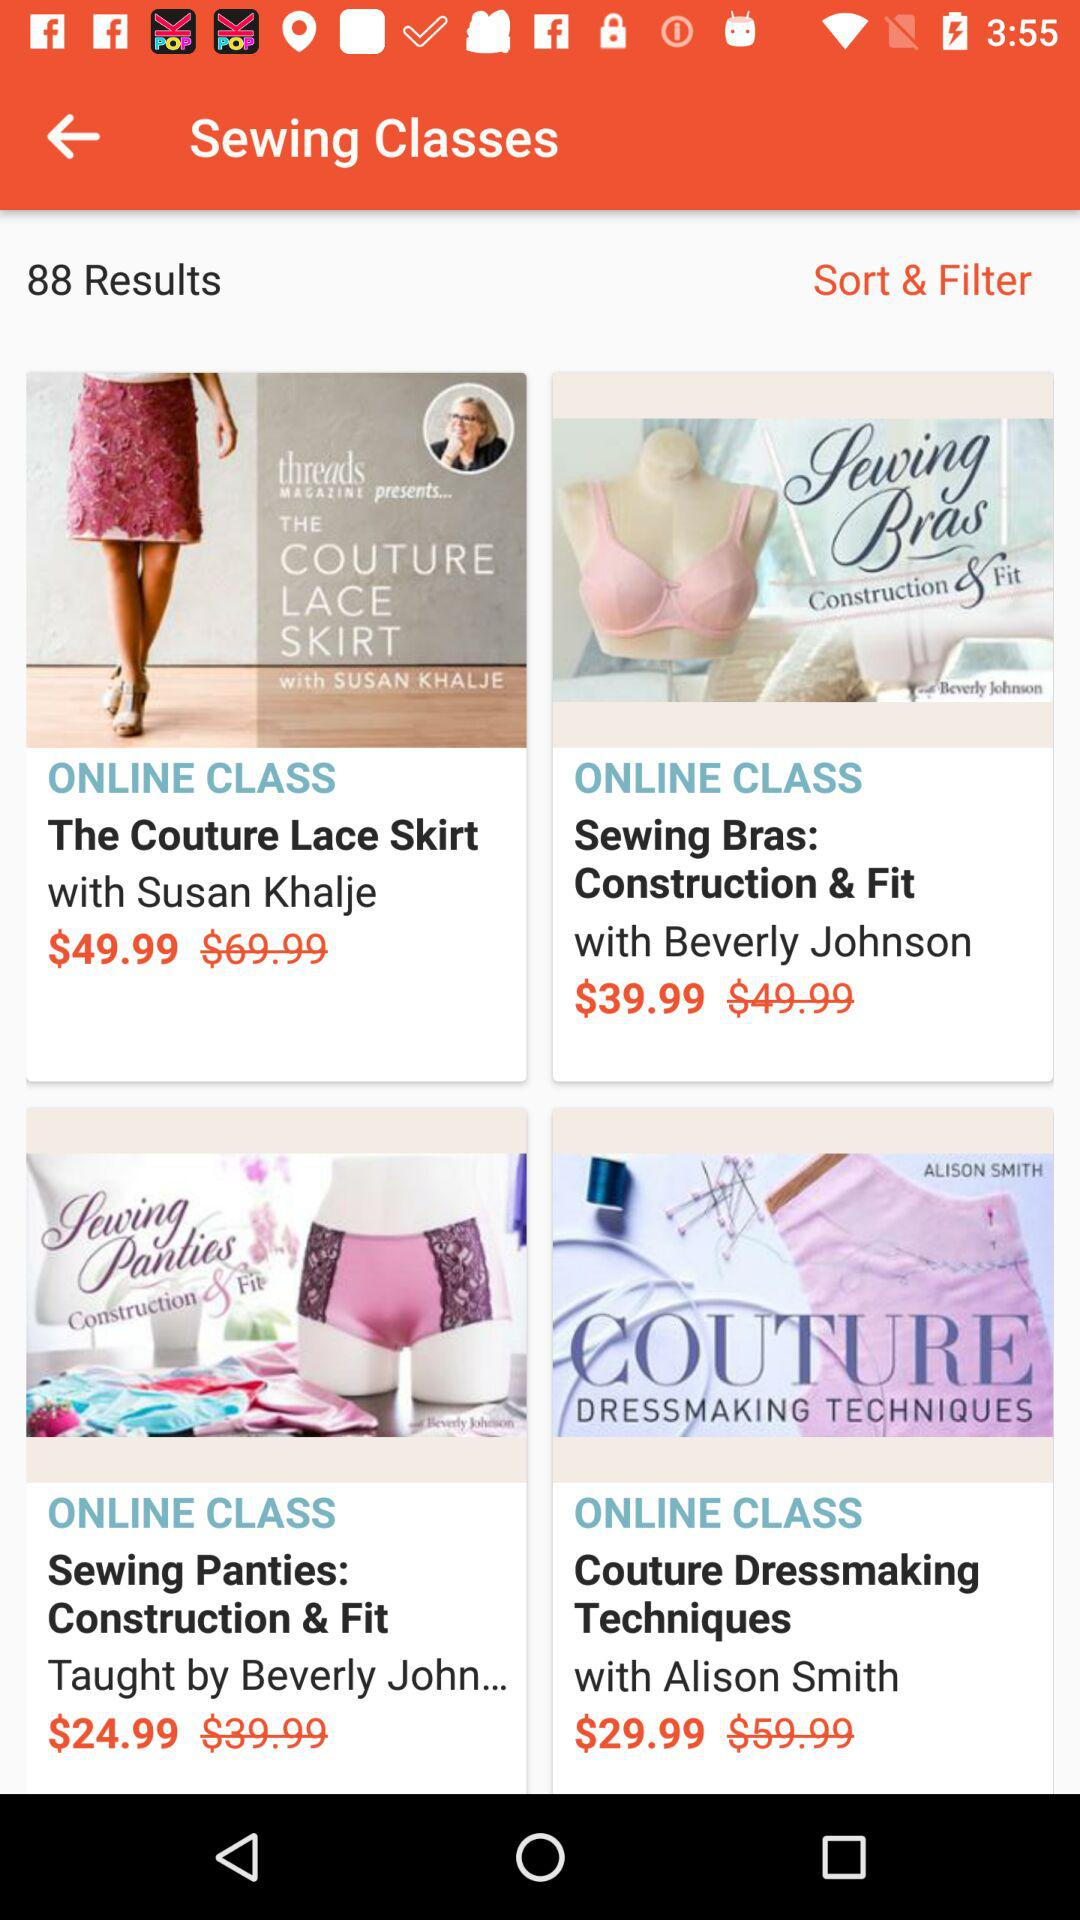How many results are there? There are 88 results. 